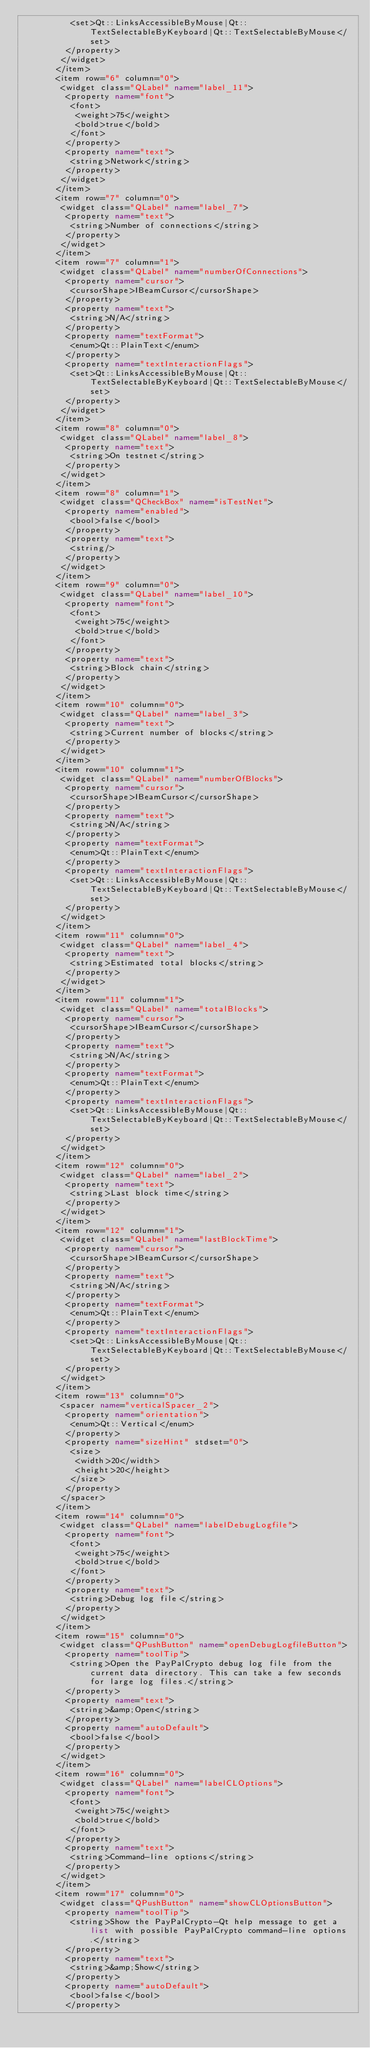Convert code to text. <code><loc_0><loc_0><loc_500><loc_500><_XML_>          <set>Qt::LinksAccessibleByMouse|Qt::TextSelectableByKeyboard|Qt::TextSelectableByMouse</set>
         </property>
        </widget>
       </item>
       <item row="6" column="0">
        <widget class="QLabel" name="label_11">
         <property name="font">
          <font>
           <weight>75</weight>
           <bold>true</bold>
          </font>
         </property>
         <property name="text">
          <string>Network</string>
         </property>
        </widget>
       </item>
       <item row="7" column="0">
        <widget class="QLabel" name="label_7">
         <property name="text">
          <string>Number of connections</string>
         </property>
        </widget>
       </item>
       <item row="7" column="1">
        <widget class="QLabel" name="numberOfConnections">
         <property name="cursor">
          <cursorShape>IBeamCursor</cursorShape>
         </property>
         <property name="text">
          <string>N/A</string>
         </property>
         <property name="textFormat">
          <enum>Qt::PlainText</enum>
         </property>
         <property name="textInteractionFlags">
          <set>Qt::LinksAccessibleByMouse|Qt::TextSelectableByKeyboard|Qt::TextSelectableByMouse</set>
         </property>
        </widget>
       </item>
       <item row="8" column="0">
        <widget class="QLabel" name="label_8">
         <property name="text">
          <string>On testnet</string>
         </property>
        </widget>
       </item>
       <item row="8" column="1">
        <widget class="QCheckBox" name="isTestNet">
         <property name="enabled">
          <bool>false</bool>
         </property>
         <property name="text">
          <string/>
         </property>
        </widget>
       </item>
       <item row="9" column="0">
        <widget class="QLabel" name="label_10">
         <property name="font">
          <font>
           <weight>75</weight>
           <bold>true</bold>
          </font>
         </property>
         <property name="text">
          <string>Block chain</string>
         </property>
        </widget>
       </item>
       <item row="10" column="0">
        <widget class="QLabel" name="label_3">
         <property name="text">
          <string>Current number of blocks</string>
         </property>
        </widget>
       </item>
       <item row="10" column="1">
        <widget class="QLabel" name="numberOfBlocks">
         <property name="cursor">
          <cursorShape>IBeamCursor</cursorShape>
         </property>
         <property name="text">
          <string>N/A</string>
         </property>
         <property name="textFormat">
          <enum>Qt::PlainText</enum>
         </property>
         <property name="textInteractionFlags">
          <set>Qt::LinksAccessibleByMouse|Qt::TextSelectableByKeyboard|Qt::TextSelectableByMouse</set>
         </property>
        </widget>
       </item>
       <item row="11" column="0">
        <widget class="QLabel" name="label_4">
         <property name="text">
          <string>Estimated total blocks</string>
         </property>
        </widget>
       </item>
       <item row="11" column="1">
        <widget class="QLabel" name="totalBlocks">
         <property name="cursor">
          <cursorShape>IBeamCursor</cursorShape>
         </property>
         <property name="text">
          <string>N/A</string>
         </property>
         <property name="textFormat">
          <enum>Qt::PlainText</enum>
         </property>
         <property name="textInteractionFlags">
          <set>Qt::LinksAccessibleByMouse|Qt::TextSelectableByKeyboard|Qt::TextSelectableByMouse</set>
         </property>
        </widget>
       </item>
       <item row="12" column="0">
        <widget class="QLabel" name="label_2">
         <property name="text">
          <string>Last block time</string>
         </property>
        </widget>
       </item>
       <item row="12" column="1">
        <widget class="QLabel" name="lastBlockTime">
         <property name="cursor">
          <cursorShape>IBeamCursor</cursorShape>
         </property>
         <property name="text">
          <string>N/A</string>
         </property>
         <property name="textFormat">
          <enum>Qt::PlainText</enum>
         </property>
         <property name="textInteractionFlags">
          <set>Qt::LinksAccessibleByMouse|Qt::TextSelectableByKeyboard|Qt::TextSelectableByMouse</set>
         </property>
        </widget>
       </item>
       <item row="13" column="0">
        <spacer name="verticalSpacer_2">
         <property name="orientation">
          <enum>Qt::Vertical</enum>
         </property>
         <property name="sizeHint" stdset="0">
          <size>
           <width>20</width>
           <height>20</height>
          </size>
         </property>
        </spacer>
       </item>
       <item row="14" column="0">
        <widget class="QLabel" name="labelDebugLogfile">
         <property name="font">
          <font>
           <weight>75</weight>
           <bold>true</bold>
          </font>
         </property>
         <property name="text">
          <string>Debug log file</string>
         </property>
        </widget>
       </item>
       <item row="15" column="0">
        <widget class="QPushButton" name="openDebugLogfileButton">
         <property name="toolTip">
          <string>Open the PayPalCrypto debug log file from the current data directory. This can take a few seconds for large log files.</string>
         </property>
         <property name="text">
          <string>&amp;Open</string>
         </property>
         <property name="autoDefault">
          <bool>false</bool>
         </property>
        </widget>
       </item>
       <item row="16" column="0">
        <widget class="QLabel" name="labelCLOptions">
         <property name="font">
          <font>
           <weight>75</weight>
           <bold>true</bold>
          </font>
         </property>
         <property name="text">
          <string>Command-line options</string>
         </property>
        </widget>
       </item>
       <item row="17" column="0">
        <widget class="QPushButton" name="showCLOptionsButton">
         <property name="toolTip">
          <string>Show the PayPalCrypto-Qt help message to get a list with possible PayPalCrypto command-line options.</string>
         </property>
         <property name="text">
          <string>&amp;Show</string>
         </property>
         <property name="autoDefault">
          <bool>false</bool>
         </property></code> 